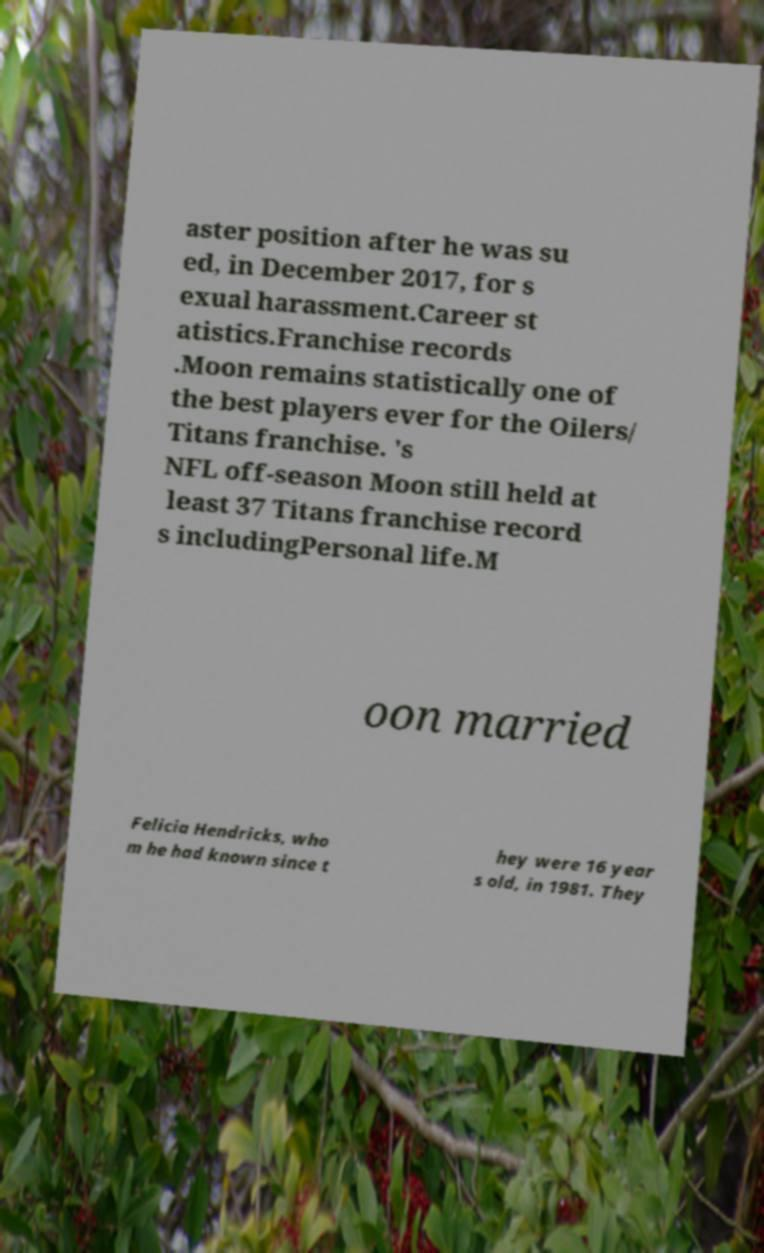Please read and relay the text visible in this image. What does it say? aster position after he was su ed, in December 2017, for s exual harassment.Career st atistics.Franchise records .Moon remains statistically one of the best players ever for the Oilers/ Titans franchise. 's NFL off-season Moon still held at least 37 Titans franchise record s includingPersonal life.M oon married Felicia Hendricks, who m he had known since t hey were 16 year s old, in 1981. They 